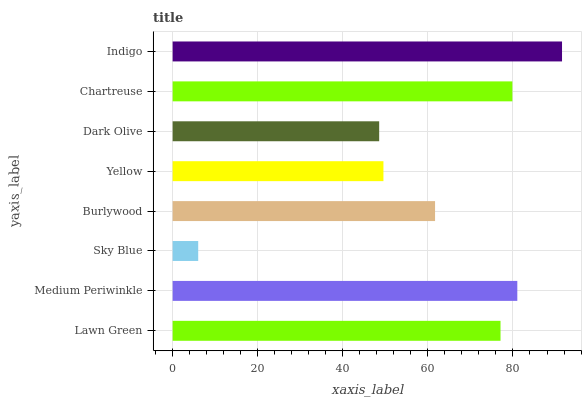Is Sky Blue the minimum?
Answer yes or no. Yes. Is Indigo the maximum?
Answer yes or no. Yes. Is Medium Periwinkle the minimum?
Answer yes or no. No. Is Medium Periwinkle the maximum?
Answer yes or no. No. Is Medium Periwinkle greater than Lawn Green?
Answer yes or no. Yes. Is Lawn Green less than Medium Periwinkle?
Answer yes or no. Yes. Is Lawn Green greater than Medium Periwinkle?
Answer yes or no. No. Is Medium Periwinkle less than Lawn Green?
Answer yes or no. No. Is Lawn Green the high median?
Answer yes or no. Yes. Is Burlywood the low median?
Answer yes or no. Yes. Is Burlywood the high median?
Answer yes or no. No. Is Dark Olive the low median?
Answer yes or no. No. 